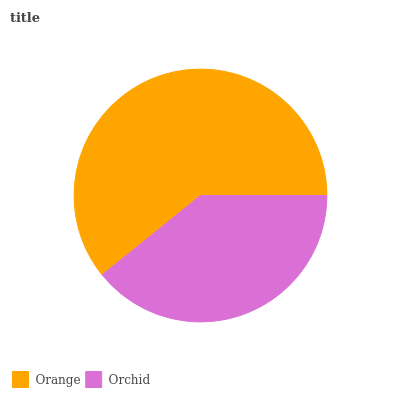Is Orchid the minimum?
Answer yes or no. Yes. Is Orange the maximum?
Answer yes or no. Yes. Is Orchid the maximum?
Answer yes or no. No. Is Orange greater than Orchid?
Answer yes or no. Yes. Is Orchid less than Orange?
Answer yes or no. Yes. Is Orchid greater than Orange?
Answer yes or no. No. Is Orange less than Orchid?
Answer yes or no. No. Is Orange the high median?
Answer yes or no. Yes. Is Orchid the low median?
Answer yes or no. Yes. Is Orchid the high median?
Answer yes or no. No. Is Orange the low median?
Answer yes or no. No. 